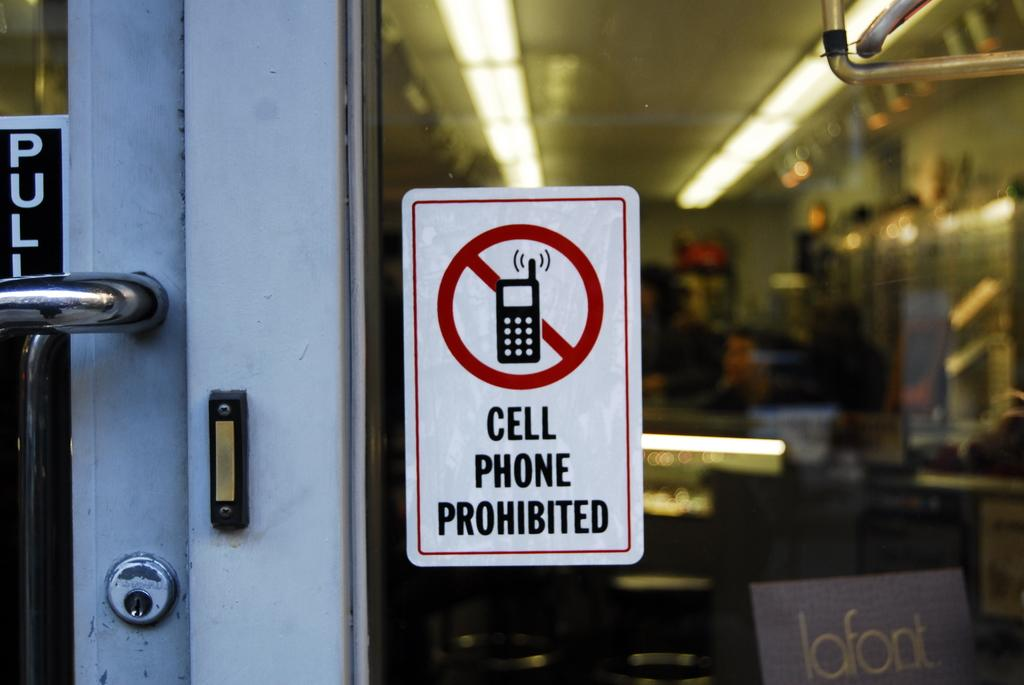What type of door is visible in the image? There is a glass door in the image. What is on the glass door? There is a poster on the glass door. What can be seen through the glass door? Lights are visible through the glass door. What type of bell can be heard ringing in the image? There is no bell present in the image, and therefore no sound can be heard. 